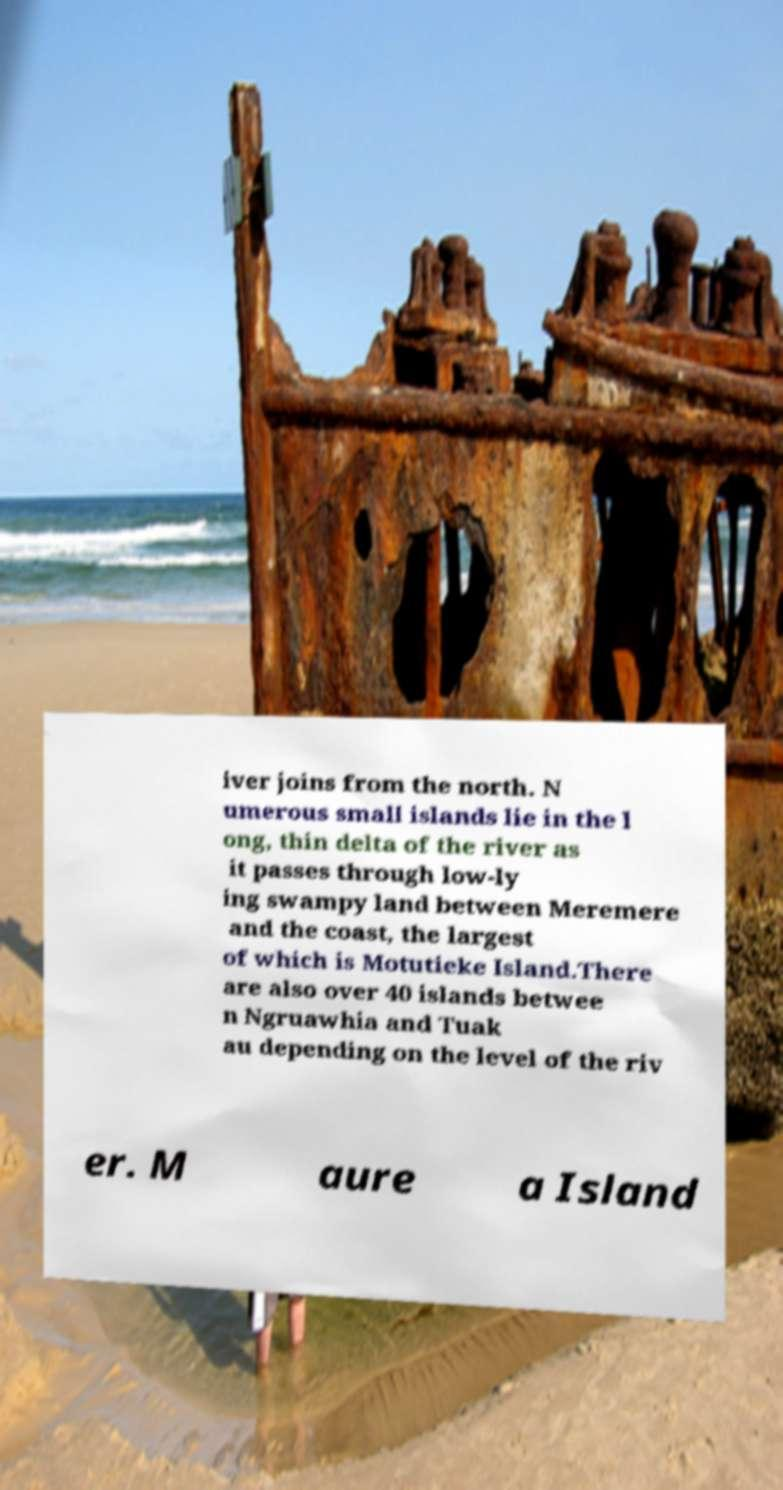For documentation purposes, I need the text within this image transcribed. Could you provide that? iver joins from the north. N umerous small islands lie in the l ong, thin delta of the river as it passes through low-ly ing swampy land between Meremere and the coast, the largest of which is Motutieke Island.There are also over 40 islands betwee n Ngruawhia and Tuak au depending on the level of the riv er. M aure a Island 